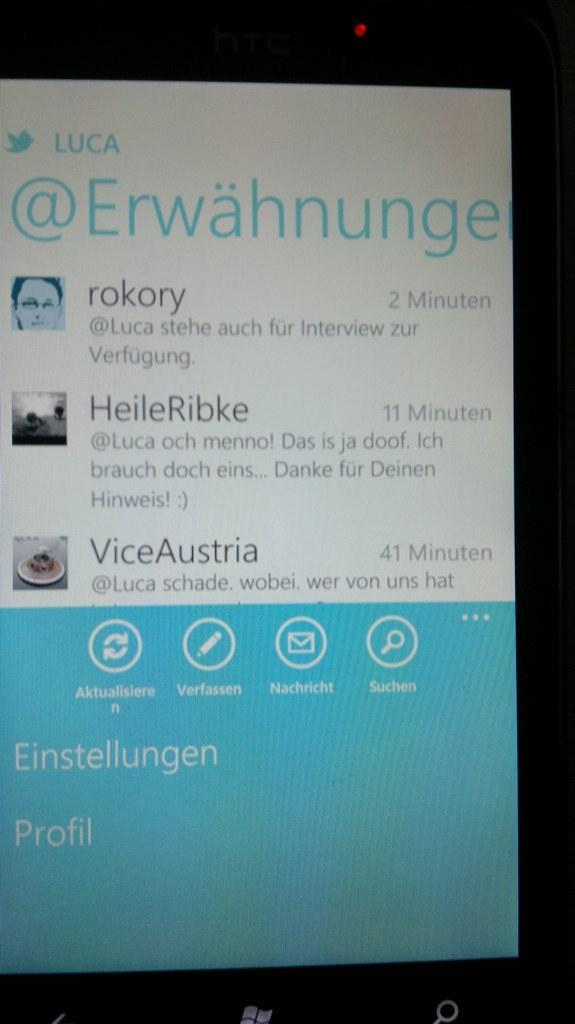Provide a one-sentence caption for the provided image. Two minutes ago a new Twitter message popped up on the screen. 